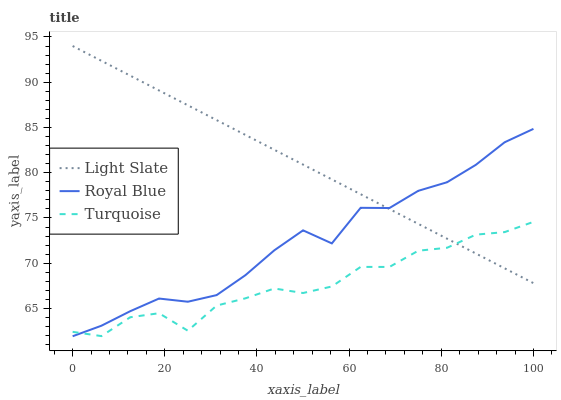Does Turquoise have the minimum area under the curve?
Answer yes or no. Yes. Does Light Slate have the maximum area under the curve?
Answer yes or no. Yes. Does Royal Blue have the minimum area under the curve?
Answer yes or no. No. Does Royal Blue have the maximum area under the curve?
Answer yes or no. No. Is Light Slate the smoothest?
Answer yes or no. Yes. Is Turquoise the roughest?
Answer yes or no. Yes. Is Royal Blue the smoothest?
Answer yes or no. No. Is Royal Blue the roughest?
Answer yes or no. No. Does Royal Blue have the lowest value?
Answer yes or no. Yes. Does Turquoise have the lowest value?
Answer yes or no. No. Does Light Slate have the highest value?
Answer yes or no. Yes. Does Royal Blue have the highest value?
Answer yes or no. No. Does Turquoise intersect Royal Blue?
Answer yes or no. Yes. Is Turquoise less than Royal Blue?
Answer yes or no. No. Is Turquoise greater than Royal Blue?
Answer yes or no. No. 